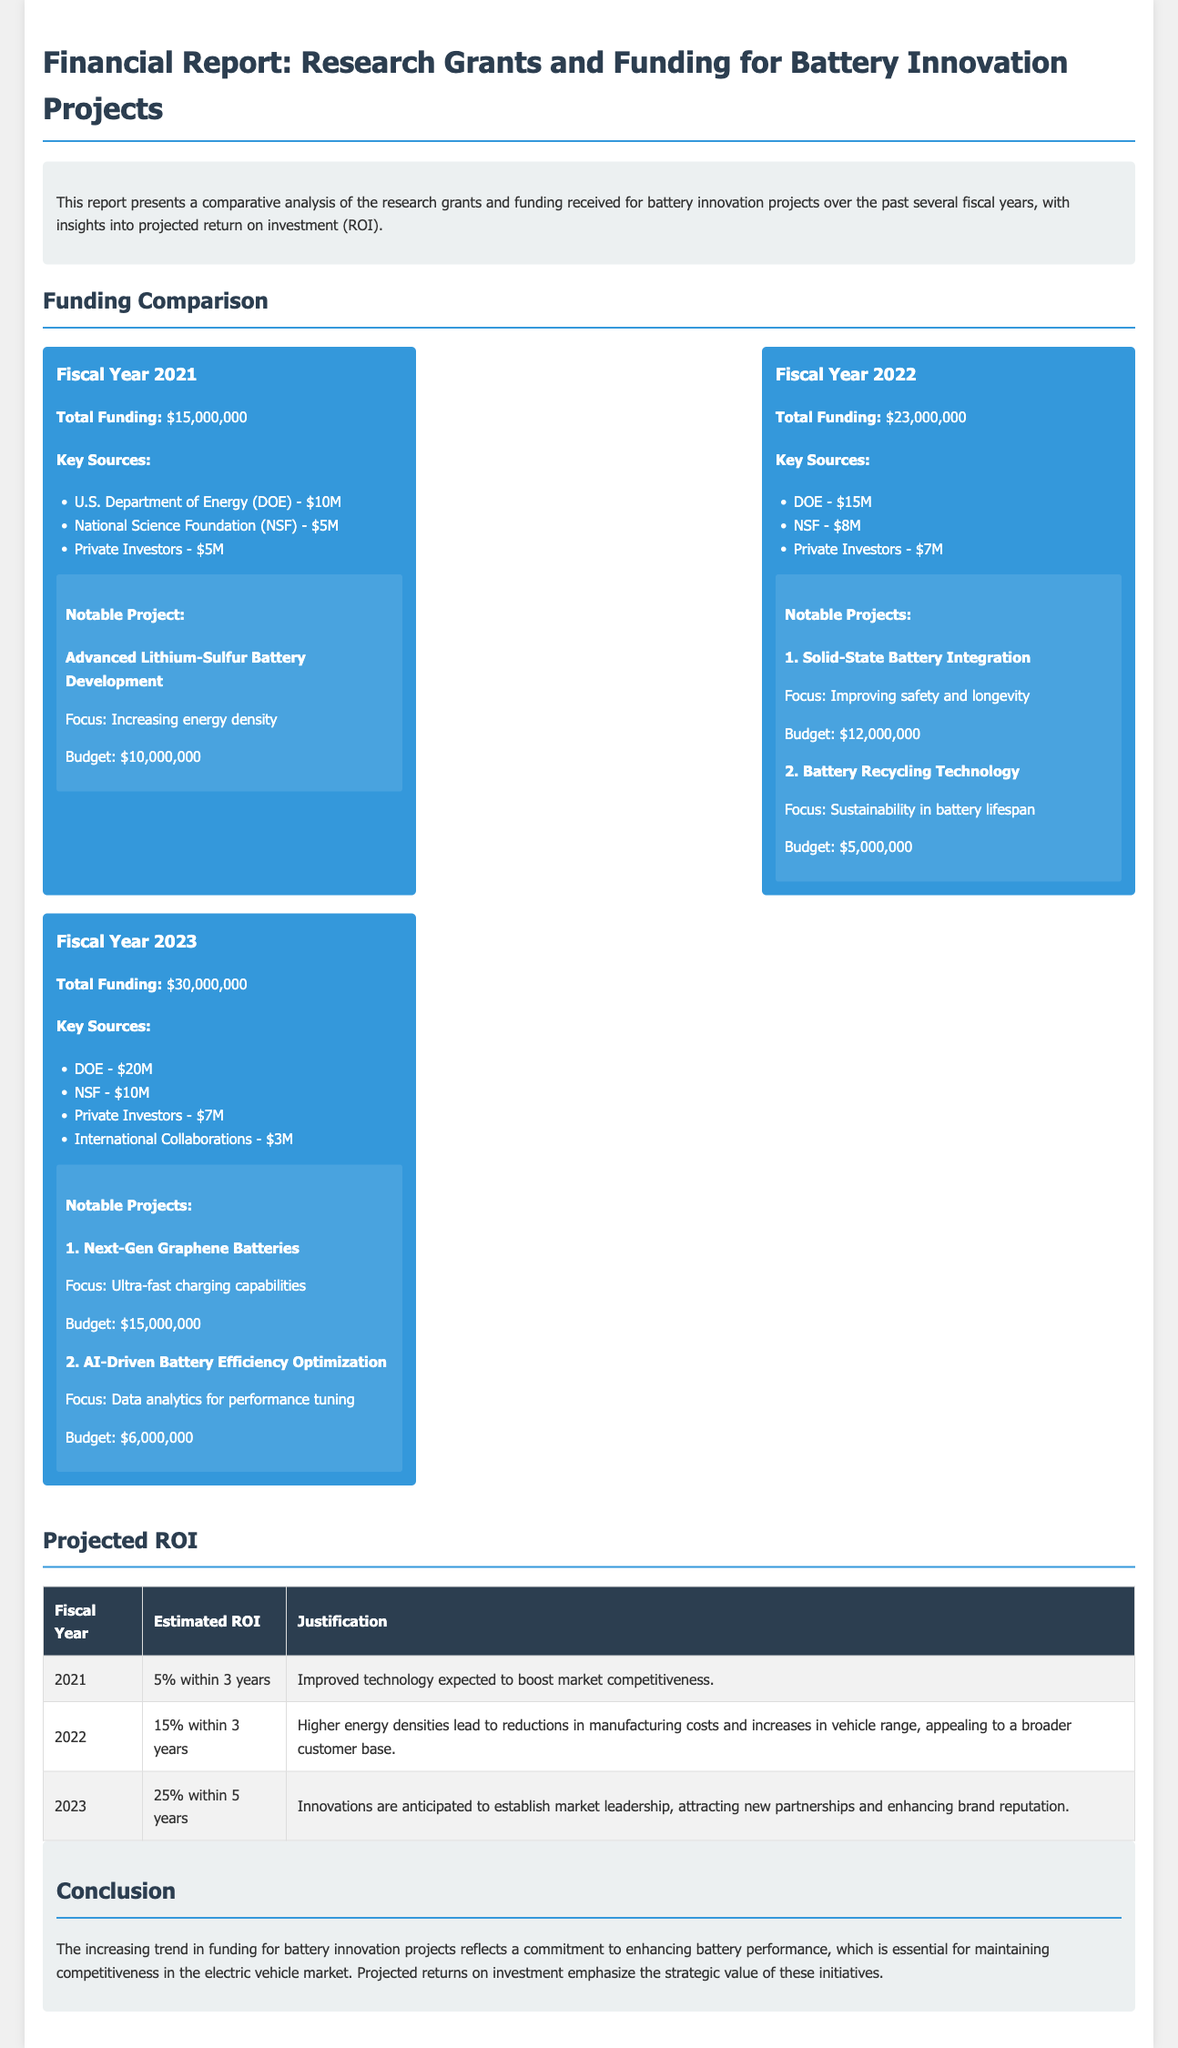What was the total funding in Fiscal Year 2021? The total funding for Fiscal Year 2021 is mentioned directly in the document as $15,000,000.
Answer: $15,000,000 Which agency provided the most funding in Fiscal Year 2023? The document specifies the U.S. Department of Energy (DOE) as providing the highest amount of funding, which is $20M.
Answer: DOE - $20M What is the budget for the Next-Gen Graphene Batteries project? The budget for the Next-Gen Graphene Batteries project is explicitly stated as $15,000,000 in the document.
Answer: $15,000,000 What is the projected ROI for the year 2022? The estimated ROI for the year 2022 is indicated as 15% within 3 years in the report.
Answer: 15% within 3 years Which year saw the highest total funding for battery innovation projects? By comparing the total funding across the years provided, Fiscal Year 2023 shows the highest total funding mentioned as $30,000,000.
Answer: $30,000,000 How many notable projects were there in Fiscal Year 2022? The document lists two notable projects for Fiscal Year 2022, which are mentioned under that specific section.
Answer: 2 What is the focus of the Advanced Lithium-Sulfur Battery Development project? The focus for the Advanced Lithium-Sulfur Battery Development project is described as increasing energy density.
Answer: Increasing energy density What is the purpose of the report? The document opens with an introduction, explaining that the report presents a comparative analysis of grants and funding for innovation projects.
Answer: Comparative analysis of research grants and funding 